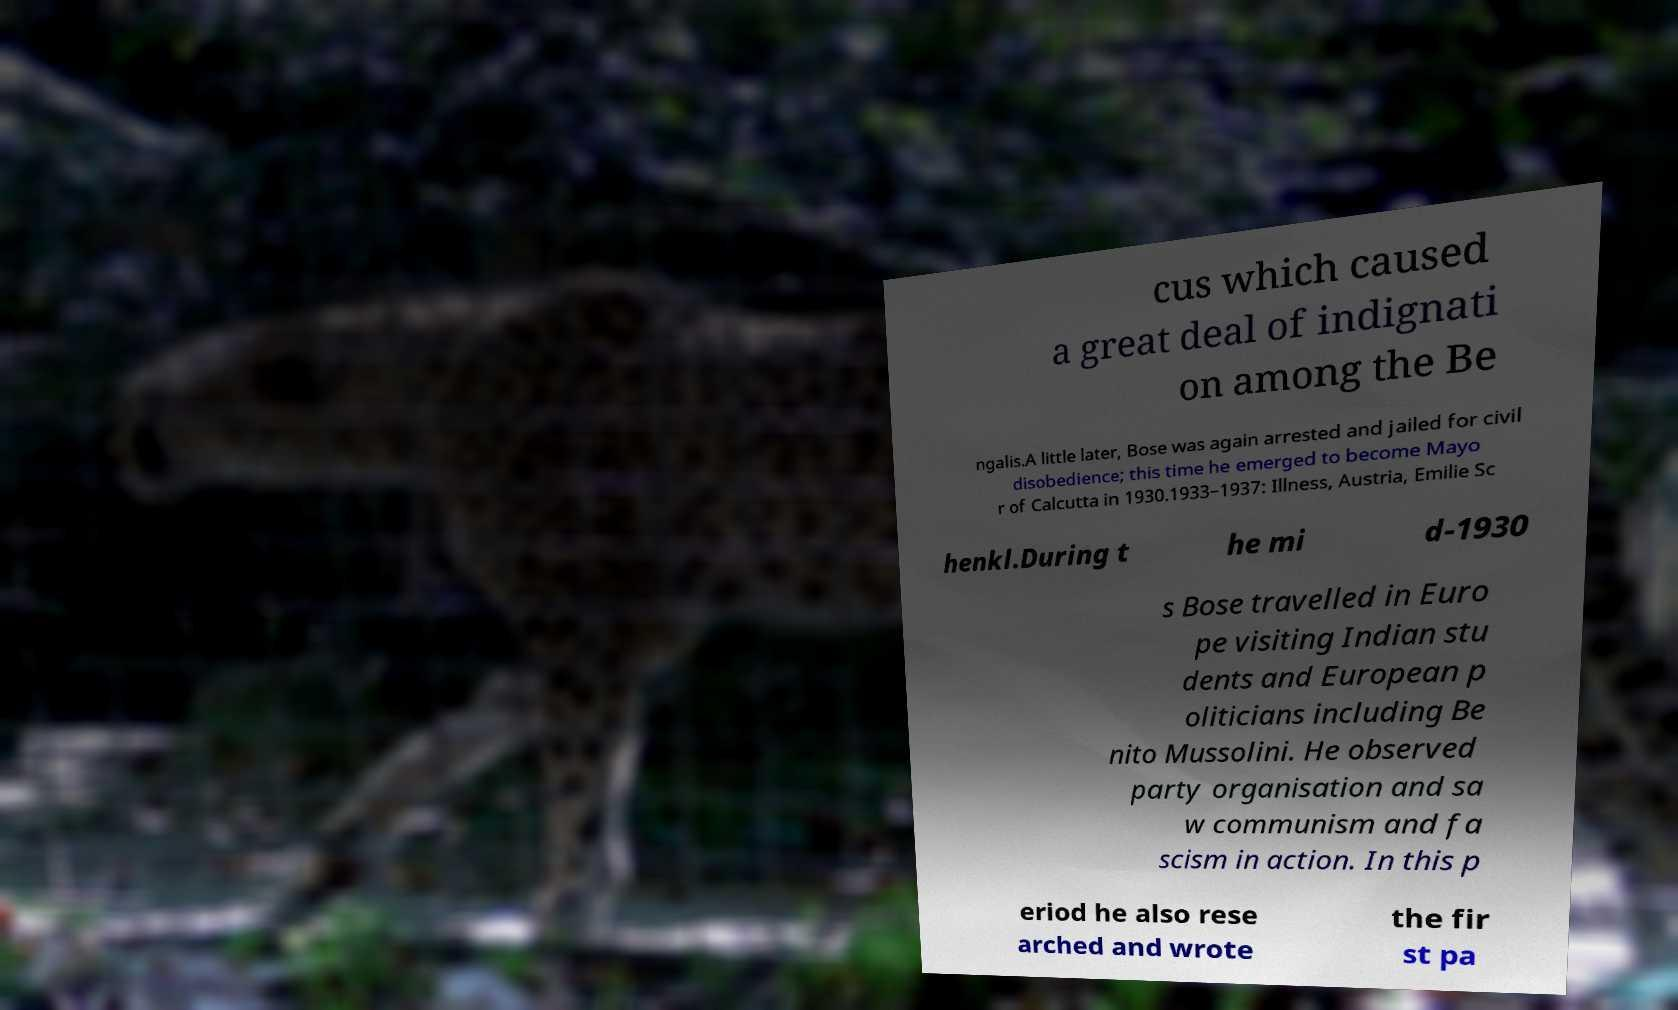Please identify and transcribe the text found in this image. cus which caused a great deal of indignati on among the Be ngalis.A little later, Bose was again arrested and jailed for civil disobedience; this time he emerged to become Mayo r of Calcutta in 1930.1933–1937: Illness, Austria, Emilie Sc henkl.During t he mi d-1930 s Bose travelled in Euro pe visiting Indian stu dents and European p oliticians including Be nito Mussolini. He observed party organisation and sa w communism and fa scism in action. In this p eriod he also rese arched and wrote the fir st pa 